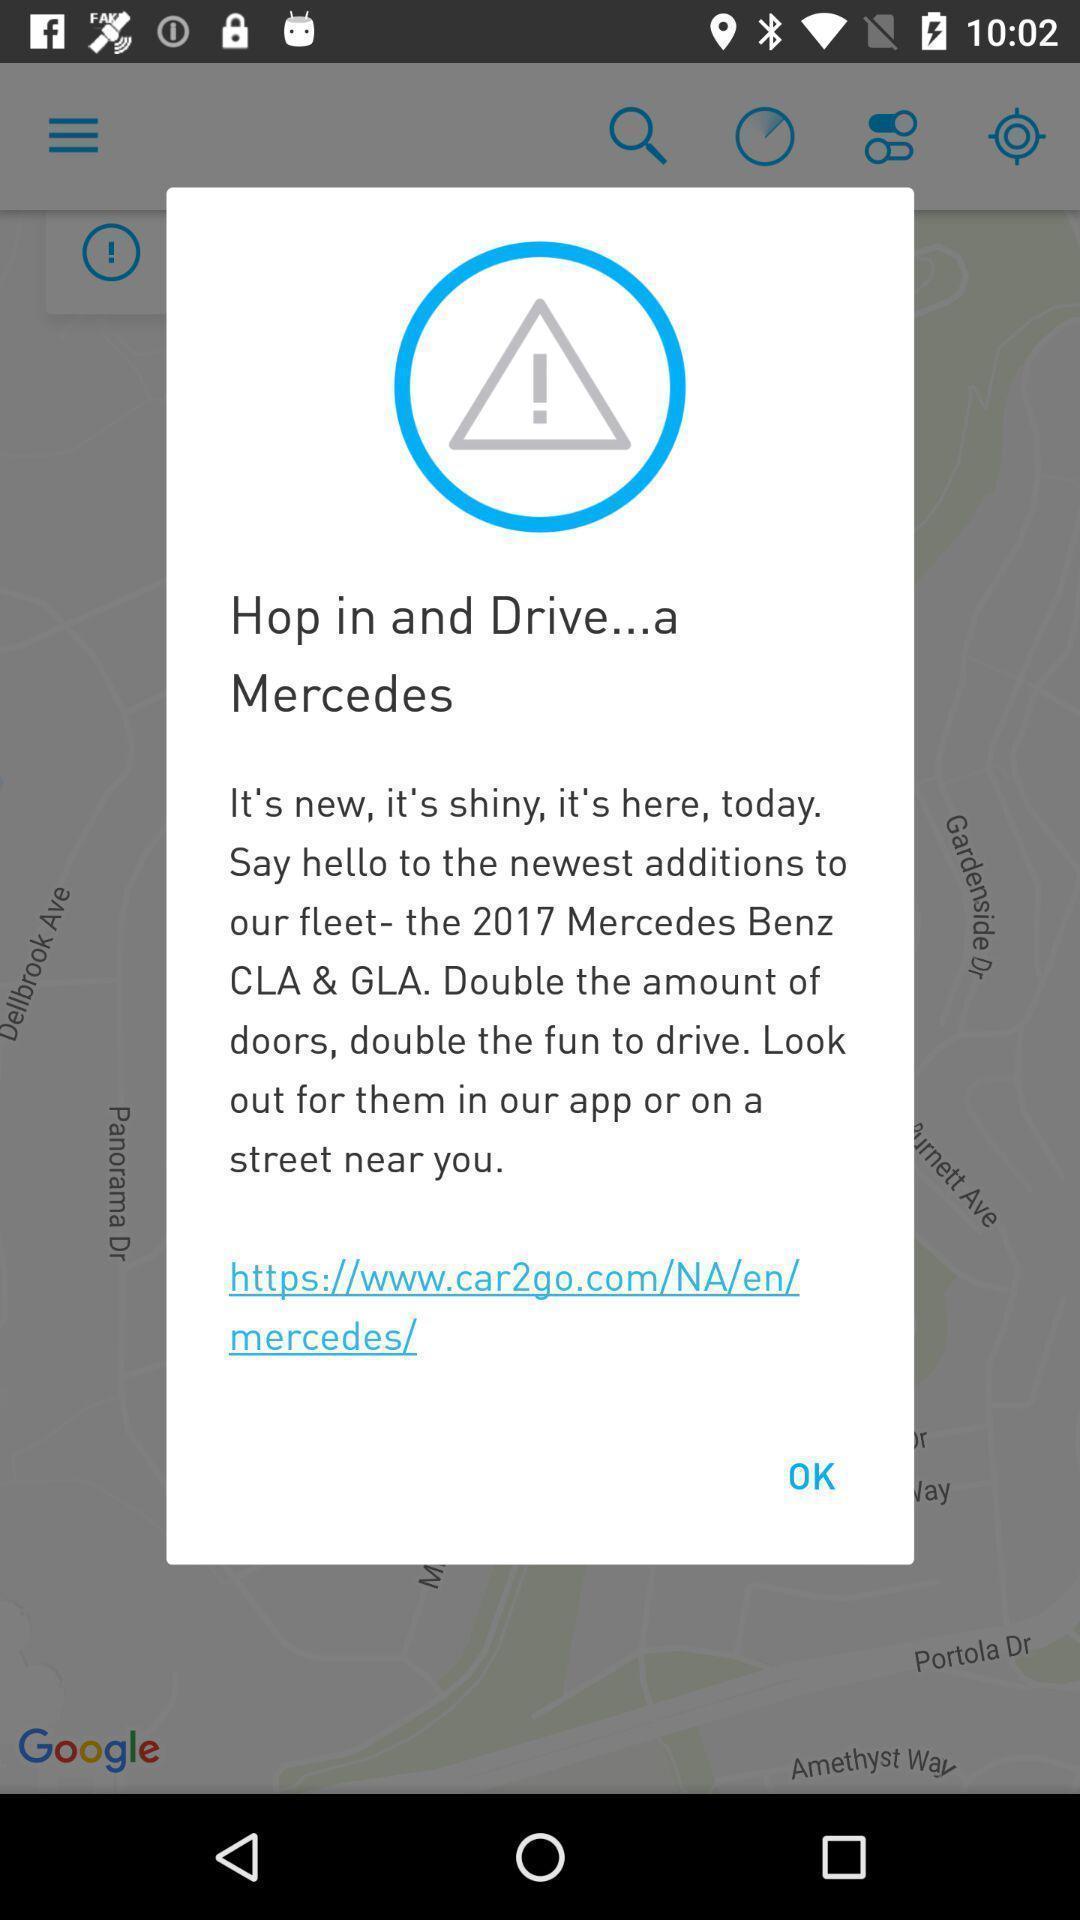Summarize the main components in this picture. Pop-up showing drive a car on a car rental app. 